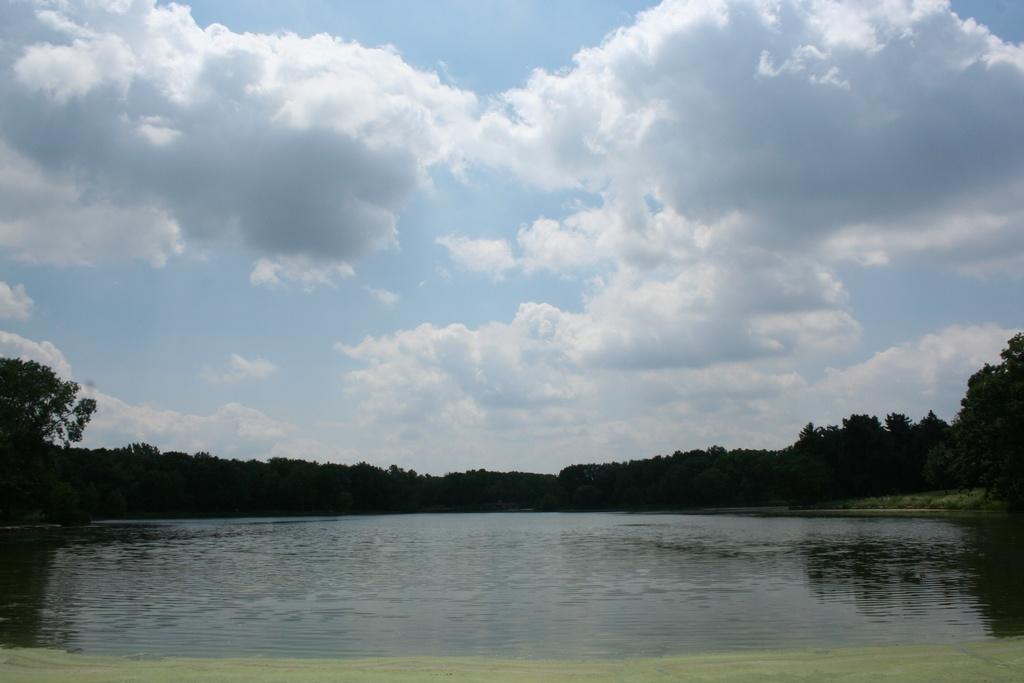What type of natural feature is present in the image? There is a river in the image. What can be seen around the river? There are trees surrounding the river. What is visible in the sky in the image? There are clouds visible in the sky. What type of plantation can be seen near the river in the image? There is no plantation present in the image; it only features a river with trees surrounding it. Is there a girl ploughing the field near the river in the image? There is no girl or ploughing activity present in the image. 